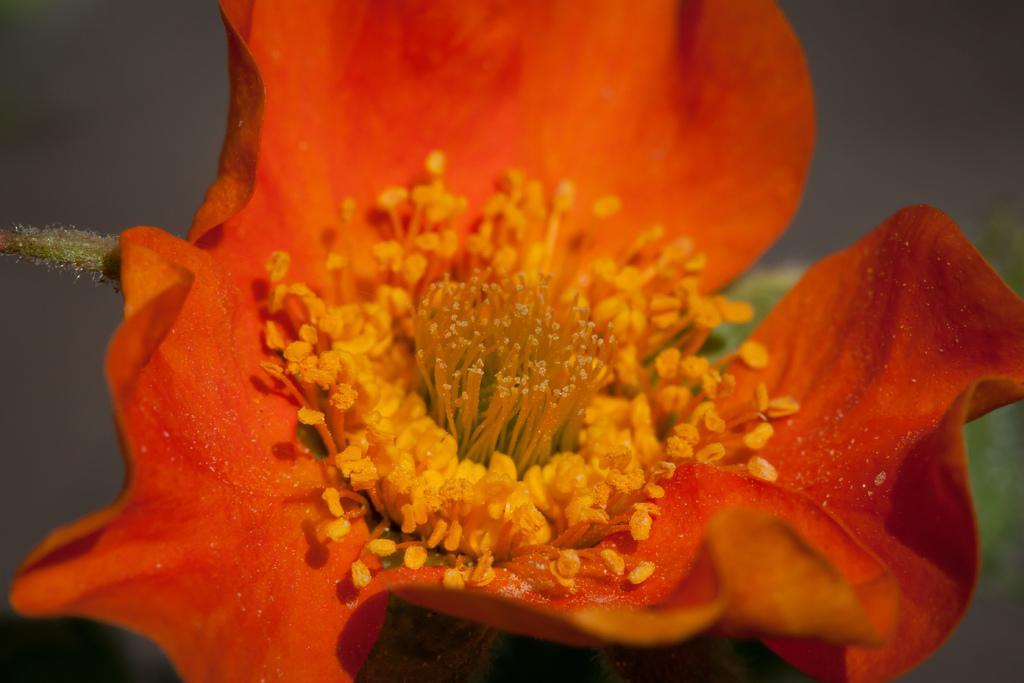What is the main subject in the foreground of the image? There is a flower in the foreground of the image. What color is the flower? The flower is orange in color. Can you describe the background of the image? The background of the image is blurry. What type of magic spell is being cast on the flower in the image? There is no indication of magic or a spell being cast in the image; it simply features a flower. 